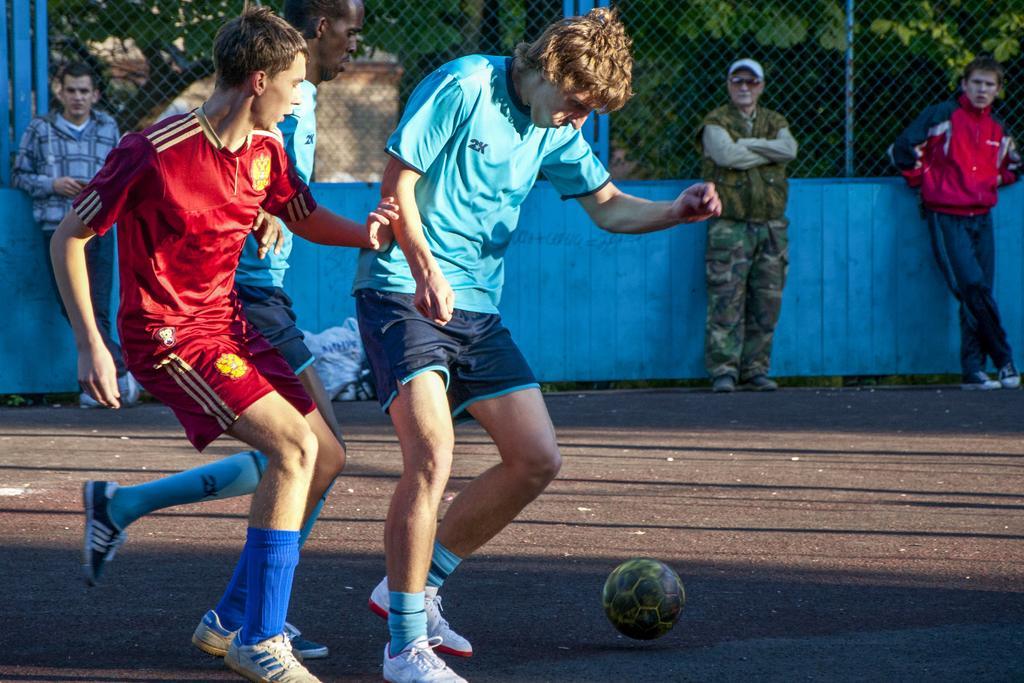Please provide a concise description of this image. This picture describes about group of people and few people playing game, in front of them we can see a ball, in the background we can find fence and few trees. 